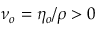<formula> <loc_0><loc_0><loc_500><loc_500>\nu _ { o } = \eta _ { o } / \rho > 0</formula> 